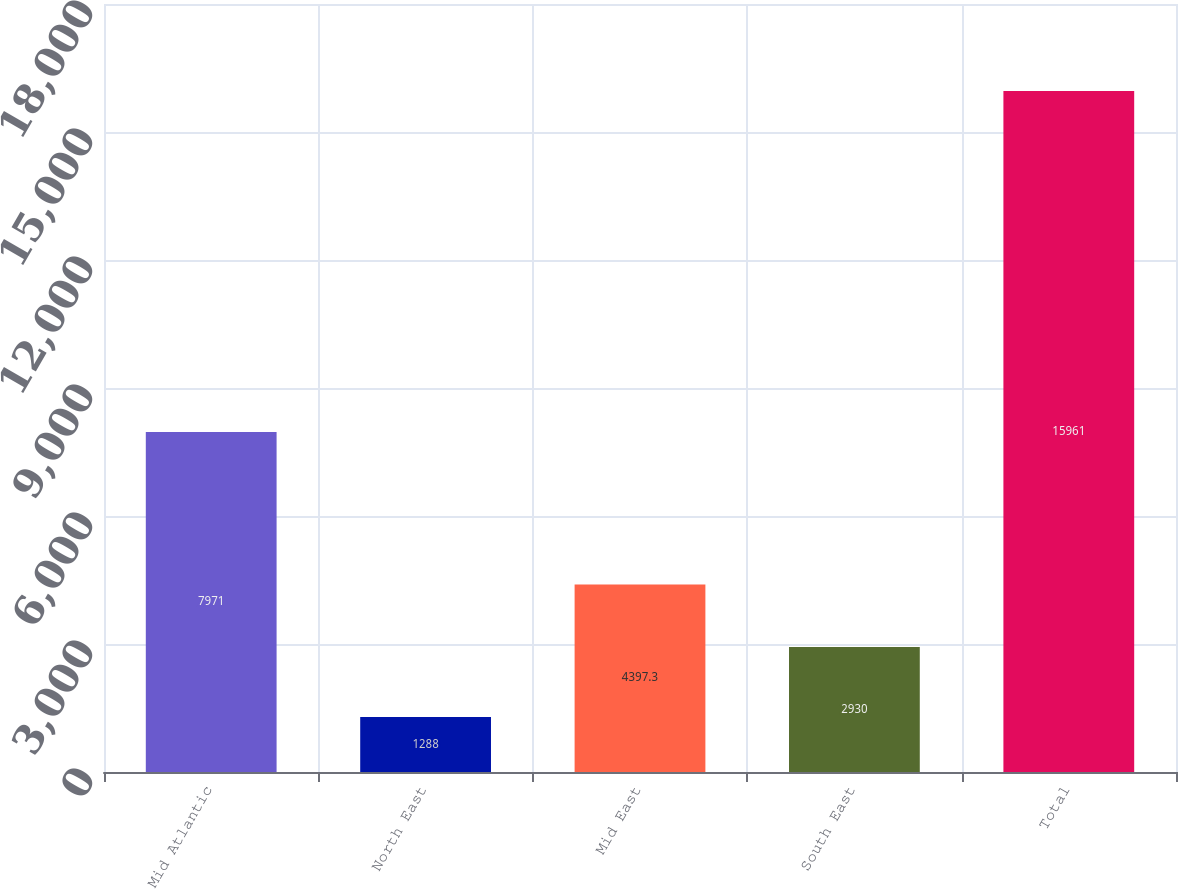<chart> <loc_0><loc_0><loc_500><loc_500><bar_chart><fcel>Mid Atlantic<fcel>North East<fcel>Mid East<fcel>South East<fcel>Total<nl><fcel>7971<fcel>1288<fcel>4397.3<fcel>2930<fcel>15961<nl></chart> 